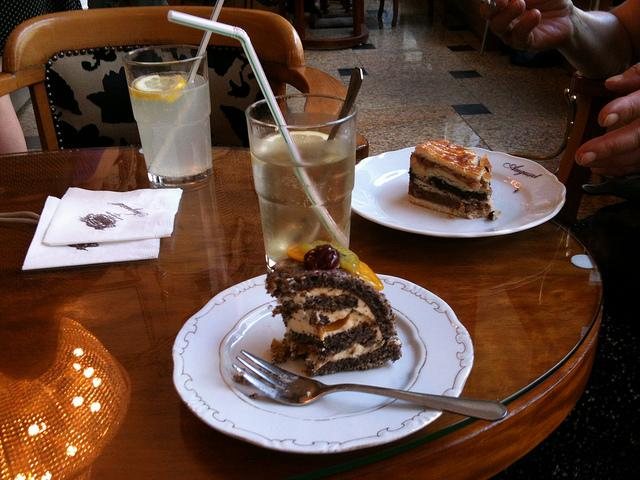How do you say the name of the item on the plate next to the cake in Italian?

Choices:
A) cucchiaio
B) grazie
C) spoon
D) forchetta forchetta 